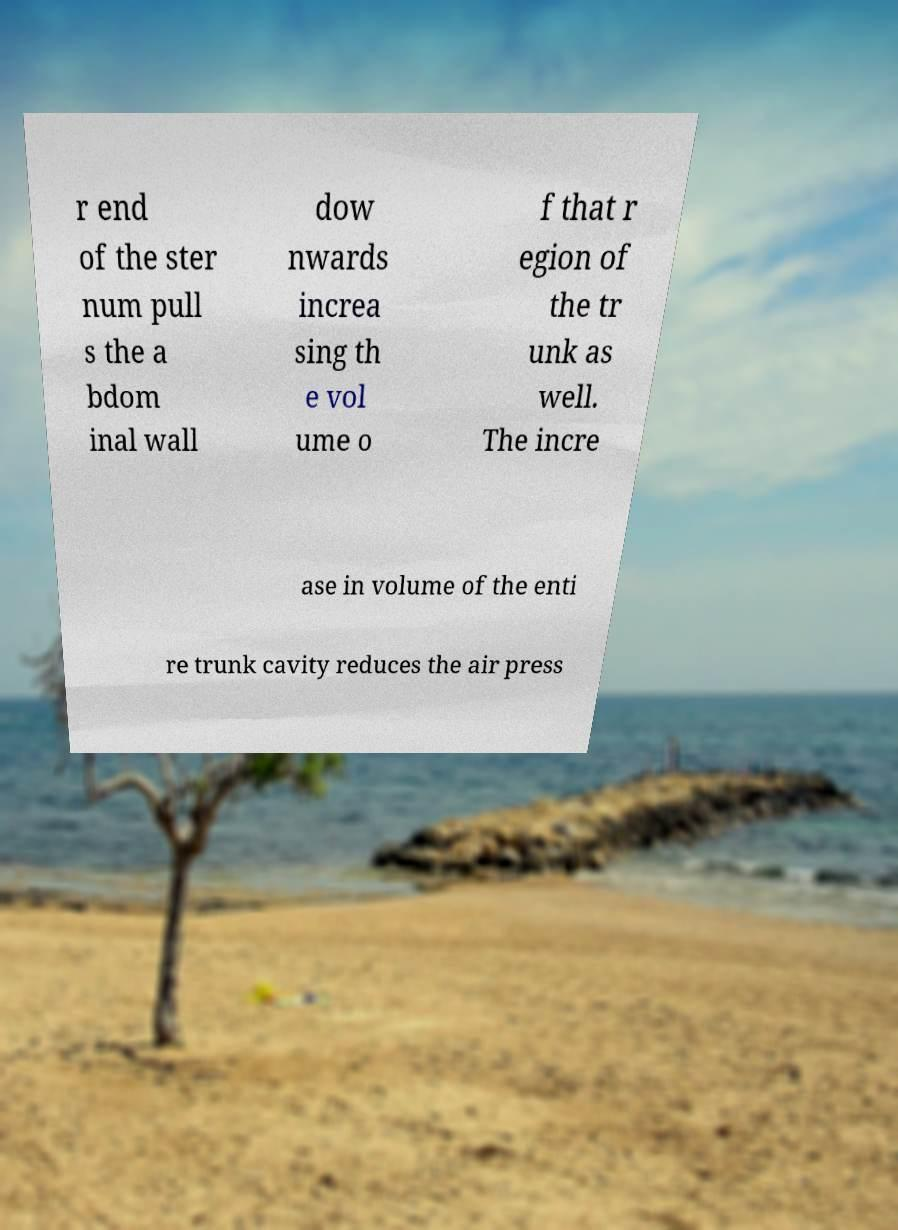What messages or text are displayed in this image? I need them in a readable, typed format. r end of the ster num pull s the a bdom inal wall dow nwards increa sing th e vol ume o f that r egion of the tr unk as well. The incre ase in volume of the enti re trunk cavity reduces the air press 